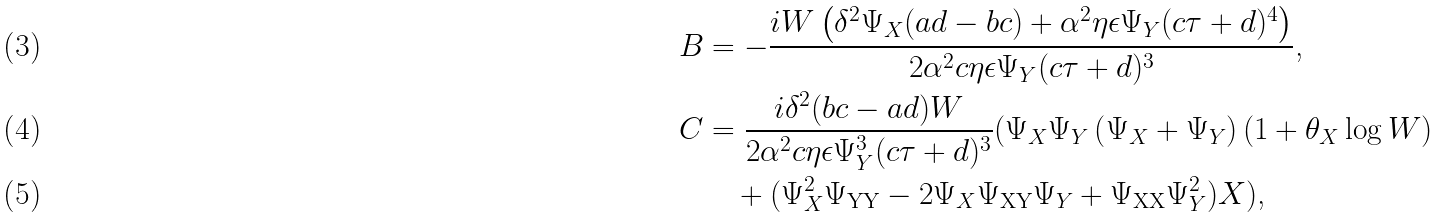Convert formula to latex. <formula><loc_0><loc_0><loc_500><loc_500>B & = - \frac { i W \left ( \delta ^ { 2 } \Psi _ { X } ( a d - b c ) + \alpha ^ { 2 } \eta \epsilon \Psi _ { Y } ( c \tau + d ) ^ { 4 } \right ) } { 2 \alpha ^ { 2 } c \eta \epsilon \Psi _ { Y } ( c \tau + d ) ^ { 3 } } \text {,} \\ C & = \frac { i \delta ^ { 2 } ( b c - a d ) W } { 2 \alpha ^ { 2 } c \eta \epsilon \Psi _ { Y } ^ { 3 } ( c \tau + d ) ^ { 3 } } ( \Psi _ { X } \Psi _ { Y } \left ( \Psi _ { X } + \Psi _ { Y } \right ) ( 1 + \theta _ { X } \log W ) \\ & \quad + ( \Psi _ { X } ^ { 2 } \Psi _ { \text {YY} } - 2 \Psi _ { X } \Psi _ { \text {XY} } \Psi _ { Y } + \Psi _ { \text {XX} } \Psi _ { Y } ^ { 2 } ) X ) \text {,}</formula> 